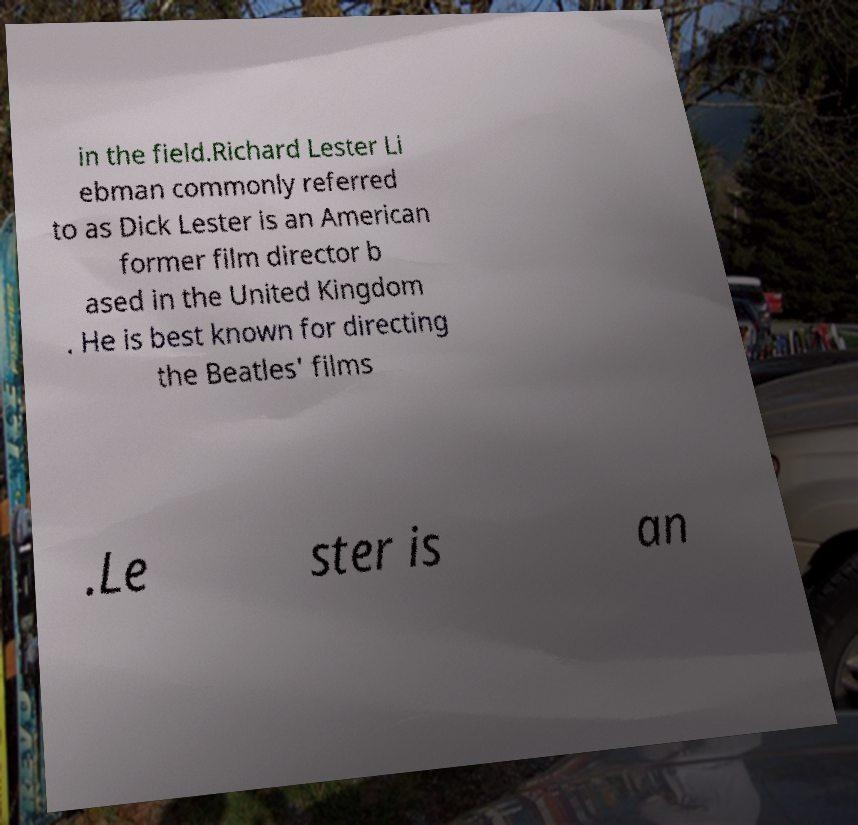Can you read and provide the text displayed in the image?This photo seems to have some interesting text. Can you extract and type it out for me? in the field.Richard Lester Li ebman commonly referred to as Dick Lester is an American former film director b ased in the United Kingdom . He is best known for directing the Beatles' films .Le ster is an 